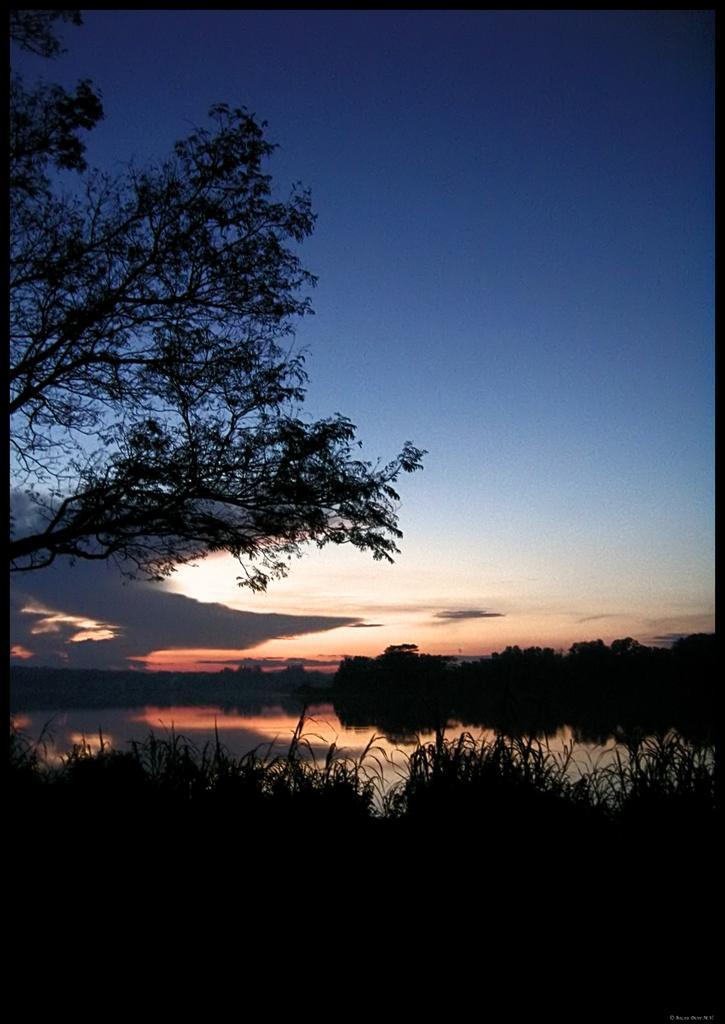Could you give a brief overview of what you see in this image? This image is taken outdoors. At the top of the image there is the sky with clouds. In the middle of the image there is a pond with water. On the left side of the image there is a tree with leaves, stems and branches. At the bottom of the image there are a few plants. On the right side of the image there are a few trees. 